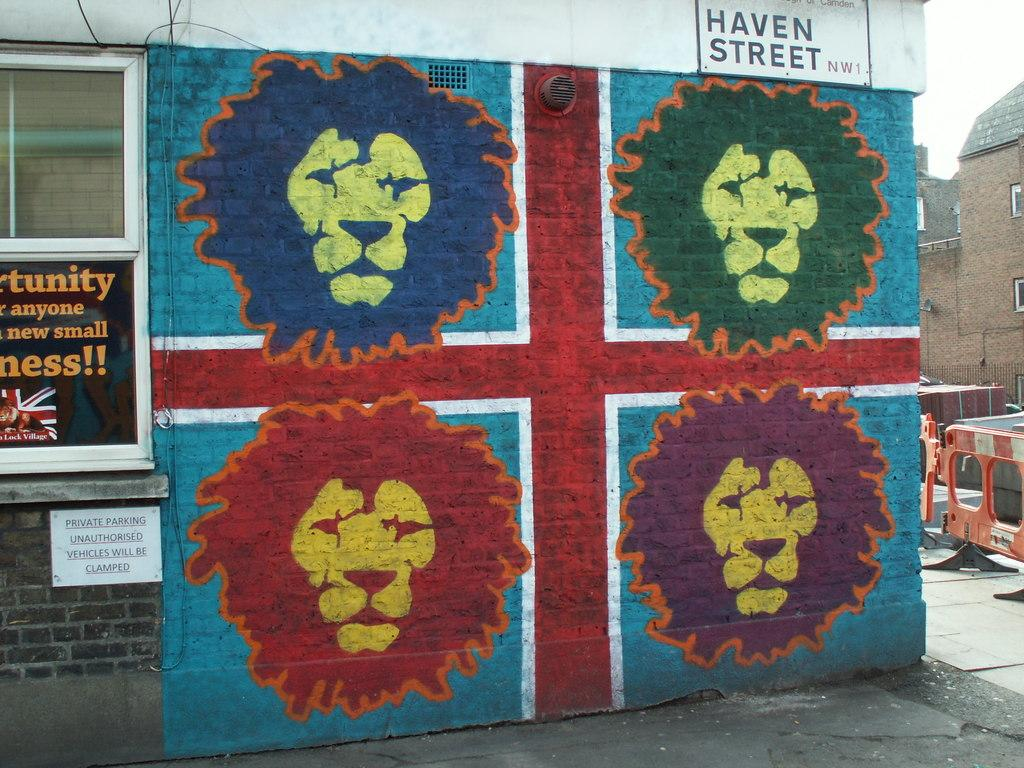<image>
Summarize the visual content of the image. A brick wall for Haven Street has four colorful lion faces. 